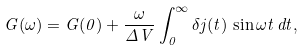Convert formula to latex. <formula><loc_0><loc_0><loc_500><loc_500>G ( \omega ) = G ( 0 ) + \frac { \omega } { \Delta V } \int _ { 0 } ^ { \infty } \delta j ( t ) \, \sin \omega t \, d t ,</formula> 